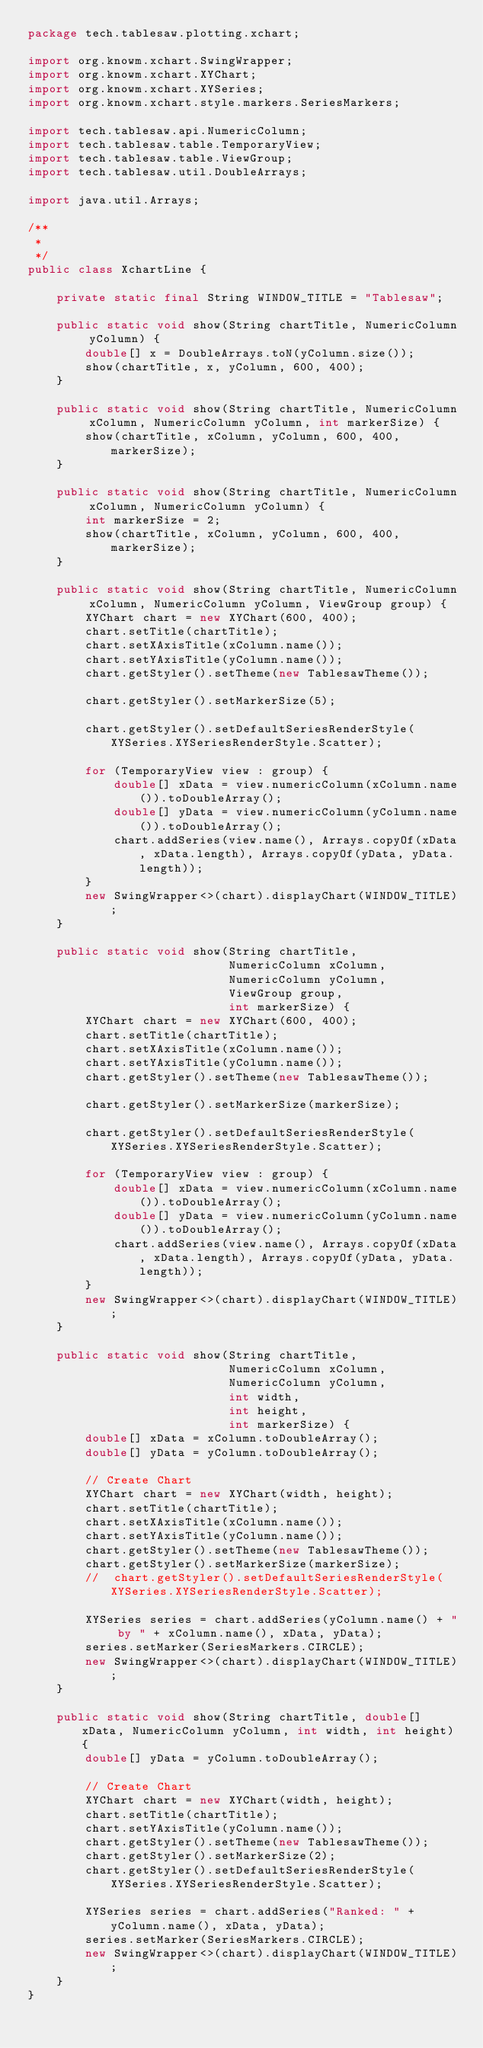<code> <loc_0><loc_0><loc_500><loc_500><_Java_>package tech.tablesaw.plotting.xchart;

import org.knowm.xchart.SwingWrapper;
import org.knowm.xchart.XYChart;
import org.knowm.xchart.XYSeries;
import org.knowm.xchart.style.markers.SeriesMarkers;

import tech.tablesaw.api.NumericColumn;
import tech.tablesaw.table.TemporaryView;
import tech.tablesaw.table.ViewGroup;
import tech.tablesaw.util.DoubleArrays;

import java.util.Arrays;

/**
 *
 */
public class XchartLine {

    private static final String WINDOW_TITLE = "Tablesaw";

    public static void show(String chartTitle, NumericColumn yColumn) {
        double[] x = DoubleArrays.toN(yColumn.size());
        show(chartTitle, x, yColumn, 600, 400);
    }

    public static void show(String chartTitle, NumericColumn xColumn, NumericColumn yColumn, int markerSize) {
        show(chartTitle, xColumn, yColumn, 600, 400, markerSize);
    }

    public static void show(String chartTitle, NumericColumn xColumn, NumericColumn yColumn) {
        int markerSize = 2;
        show(chartTitle, xColumn, yColumn, 600, 400, markerSize);
    }

    public static void show(String chartTitle, NumericColumn xColumn, NumericColumn yColumn, ViewGroup group) {
        XYChart chart = new XYChart(600, 400);
        chart.setTitle(chartTitle);
        chart.setXAxisTitle(xColumn.name());
        chart.setYAxisTitle(yColumn.name());
        chart.getStyler().setTheme(new TablesawTheme());

        chart.getStyler().setMarkerSize(5);

        chart.getStyler().setDefaultSeriesRenderStyle(XYSeries.XYSeriesRenderStyle.Scatter);

        for (TemporaryView view : group) {
            double[] xData = view.numericColumn(xColumn.name()).toDoubleArray();
            double[] yData = view.numericColumn(yColumn.name()).toDoubleArray();
            chart.addSeries(view.name(), Arrays.copyOf(xData, xData.length), Arrays.copyOf(yData, yData.length));
        }
        new SwingWrapper<>(chart).displayChart(WINDOW_TITLE);
    }

    public static void show(String chartTitle,
                            NumericColumn xColumn,
                            NumericColumn yColumn,
                            ViewGroup group,
                            int markerSize) {
        XYChart chart = new XYChart(600, 400);
        chart.setTitle(chartTitle);
        chart.setXAxisTitle(xColumn.name());
        chart.setYAxisTitle(yColumn.name());
        chart.getStyler().setTheme(new TablesawTheme());

        chart.getStyler().setMarkerSize(markerSize);

        chart.getStyler().setDefaultSeriesRenderStyle(XYSeries.XYSeriesRenderStyle.Scatter);

        for (TemporaryView view : group) {
            double[] xData = view.numericColumn(xColumn.name()).toDoubleArray();
            double[] yData = view.numericColumn(yColumn.name()).toDoubleArray();
            chart.addSeries(view.name(), Arrays.copyOf(xData, xData.length), Arrays.copyOf(yData, yData.length));
        }
        new SwingWrapper<>(chart).displayChart(WINDOW_TITLE);
    }

    public static void show(String chartTitle,
                            NumericColumn xColumn,
                            NumericColumn yColumn,
                            int width,
                            int height,
                            int markerSize) {
        double[] xData = xColumn.toDoubleArray();
        double[] yData = yColumn.toDoubleArray();

        // Create Chart
        XYChart chart = new XYChart(width, height);
        chart.setTitle(chartTitle);
        chart.setXAxisTitle(xColumn.name());
        chart.setYAxisTitle(yColumn.name());
        chart.getStyler().setTheme(new TablesawTheme());
        chart.getStyler().setMarkerSize(markerSize);
        //  chart.getStyler().setDefaultSeriesRenderStyle(XYSeries.XYSeriesRenderStyle.Scatter);

        XYSeries series = chart.addSeries(yColumn.name() + " by " + xColumn.name(), xData, yData);
        series.setMarker(SeriesMarkers.CIRCLE);
        new SwingWrapper<>(chart).displayChart(WINDOW_TITLE);
    }

    public static void show(String chartTitle, double[] xData, NumericColumn yColumn, int width, int height) {
        double[] yData = yColumn.toDoubleArray();

        // Create Chart
        XYChart chart = new XYChart(width, height);
        chart.setTitle(chartTitle);
        chart.setYAxisTitle(yColumn.name());
        chart.getStyler().setTheme(new TablesawTheme());
        chart.getStyler().setMarkerSize(2);
        chart.getStyler().setDefaultSeriesRenderStyle(XYSeries.XYSeriesRenderStyle.Scatter);

        XYSeries series = chart.addSeries("Ranked: " + yColumn.name(), xData, yData);
        series.setMarker(SeriesMarkers.CIRCLE);
        new SwingWrapper<>(chart).displayChart(WINDOW_TITLE);
    }
}
</code> 